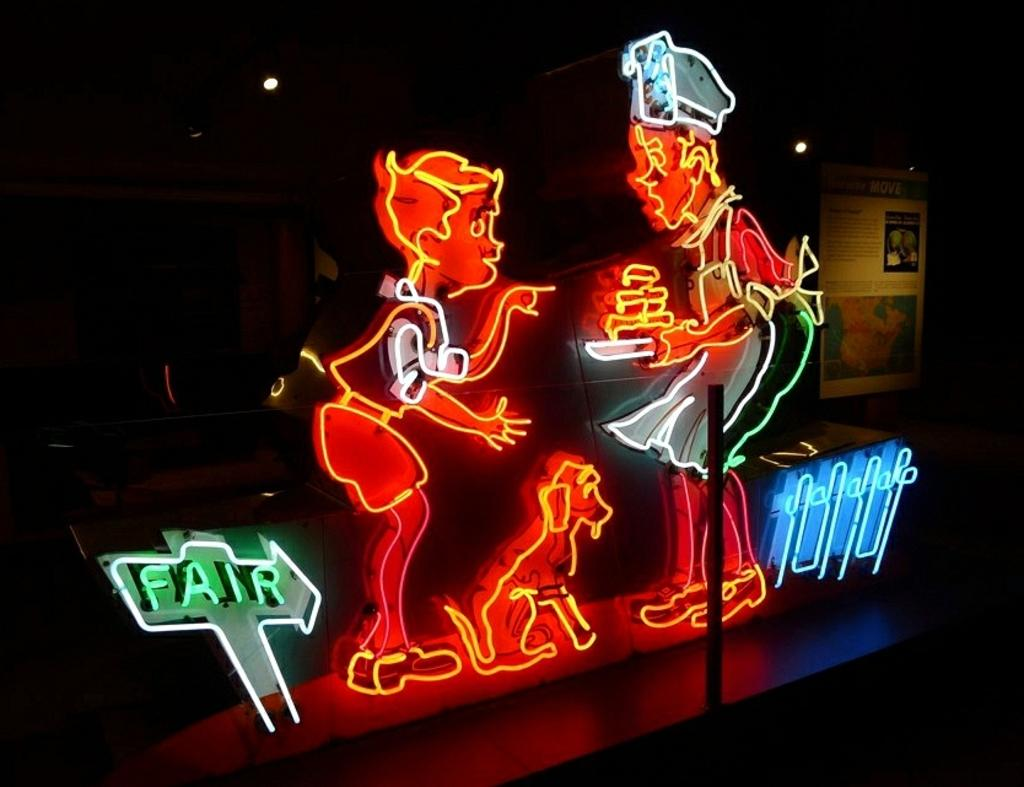How many people are present in the image? There are two people in the image. What other living creature is in the image? There is a dog in the image. What type of signage is present in the image? There are name boards in the image. What type of illumination is visible in the image? There are lights in the image. Can you describe the unspecified objects in the image? Unfortunately, the provided facts do not specify the nature of these objects. What is the color of the background in the image? The background of the image is dark. What type of degree is the person holding in the image? There is no person holding a degree in the image; the provided facts only mention the presence of name boards. What type of skirt is the dog wearing in the image? Dogs do not wear skirts, and there is no mention of clothing in the image. 